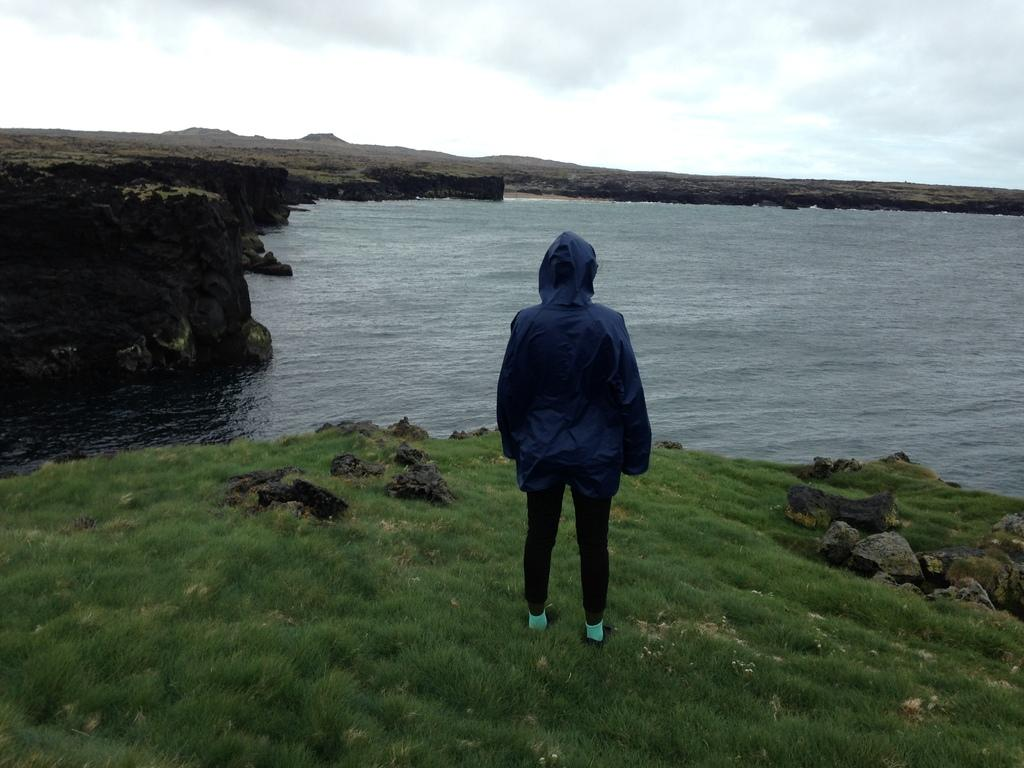What is the person in the image standing on? The person is standing on the grass. What else can be seen on the grass in the image? There are stones on the grass on the ground. What is visible in the background of the image? Water, a cliff, and clouds are present in the background. What type of condition does the ladybug have in the image? There is no ladybug present in the image. 